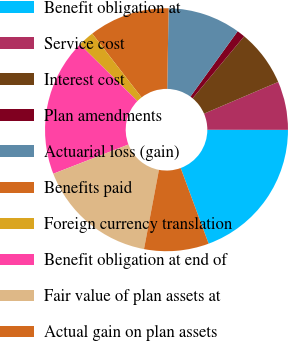Convert chart to OTSL. <chart><loc_0><loc_0><loc_500><loc_500><pie_chart><fcel>Benefit obligation at<fcel>Service cost<fcel>Interest cost<fcel>Plan amendments<fcel>Actuarial loss (gain)<fcel>Benefits paid<fcel>Foreign currency translation<fcel>Benefit obligation at end of<fcel>Fair value of plan assets at<fcel>Actual gain on plan assets<nl><fcel>19.35%<fcel>6.45%<fcel>7.53%<fcel>1.08%<fcel>9.68%<fcel>10.75%<fcel>2.15%<fcel>18.28%<fcel>16.13%<fcel>8.6%<nl></chart> 